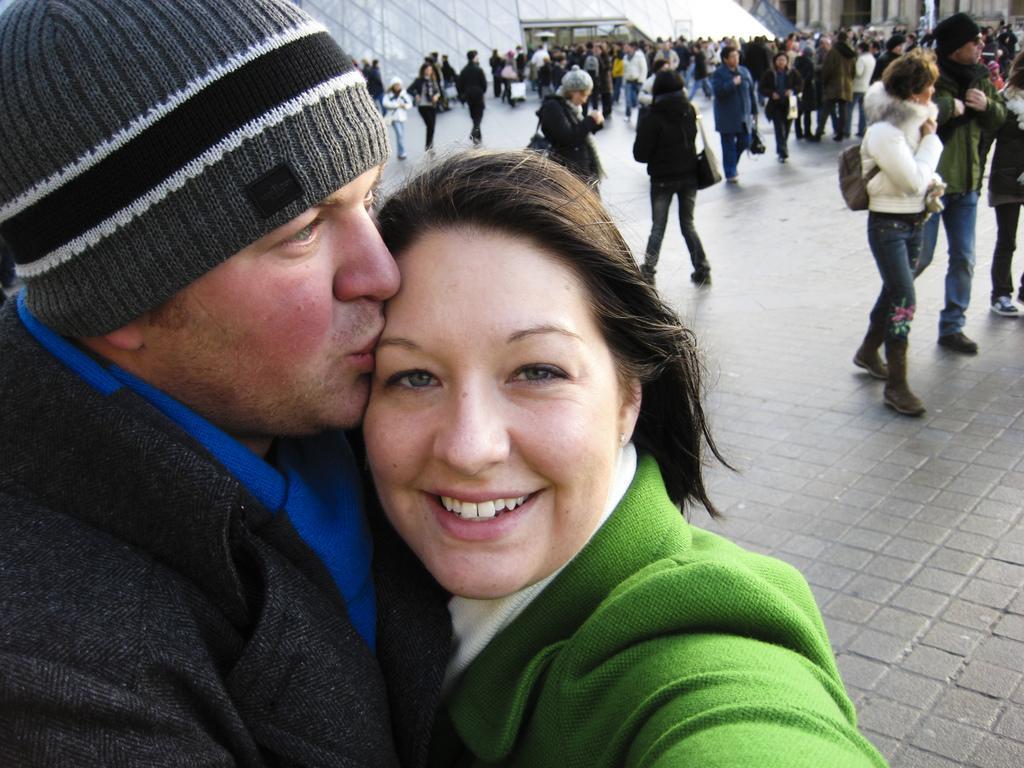Please provide a concise description of this image. In this image on the left there is a man, he wears a jacket, cap, he is kissing a woman, she wears a jacket. On the right there is a woman, she wears a jacket, bag, trouser, shoes and there is a man, he wears a jacket, trouser, shoes. In the middle there are many people, buildings. 